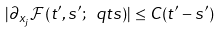Convert formula to latex. <formula><loc_0><loc_0><loc_500><loc_500>| \partial _ { x _ { j } } \mathcal { F } ( t ^ { \prime } , s ^ { \prime } ; \ q t s ) | \leq C ( t ^ { \prime } - s ^ { \prime } )</formula> 